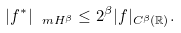<formula> <loc_0><loc_0><loc_500><loc_500>| f ^ { * } | _ { \ m H ^ { \beta } } \leq 2 ^ { \beta } | f | _ { C ^ { \beta } ( \mathbb { R } ) } .</formula> 